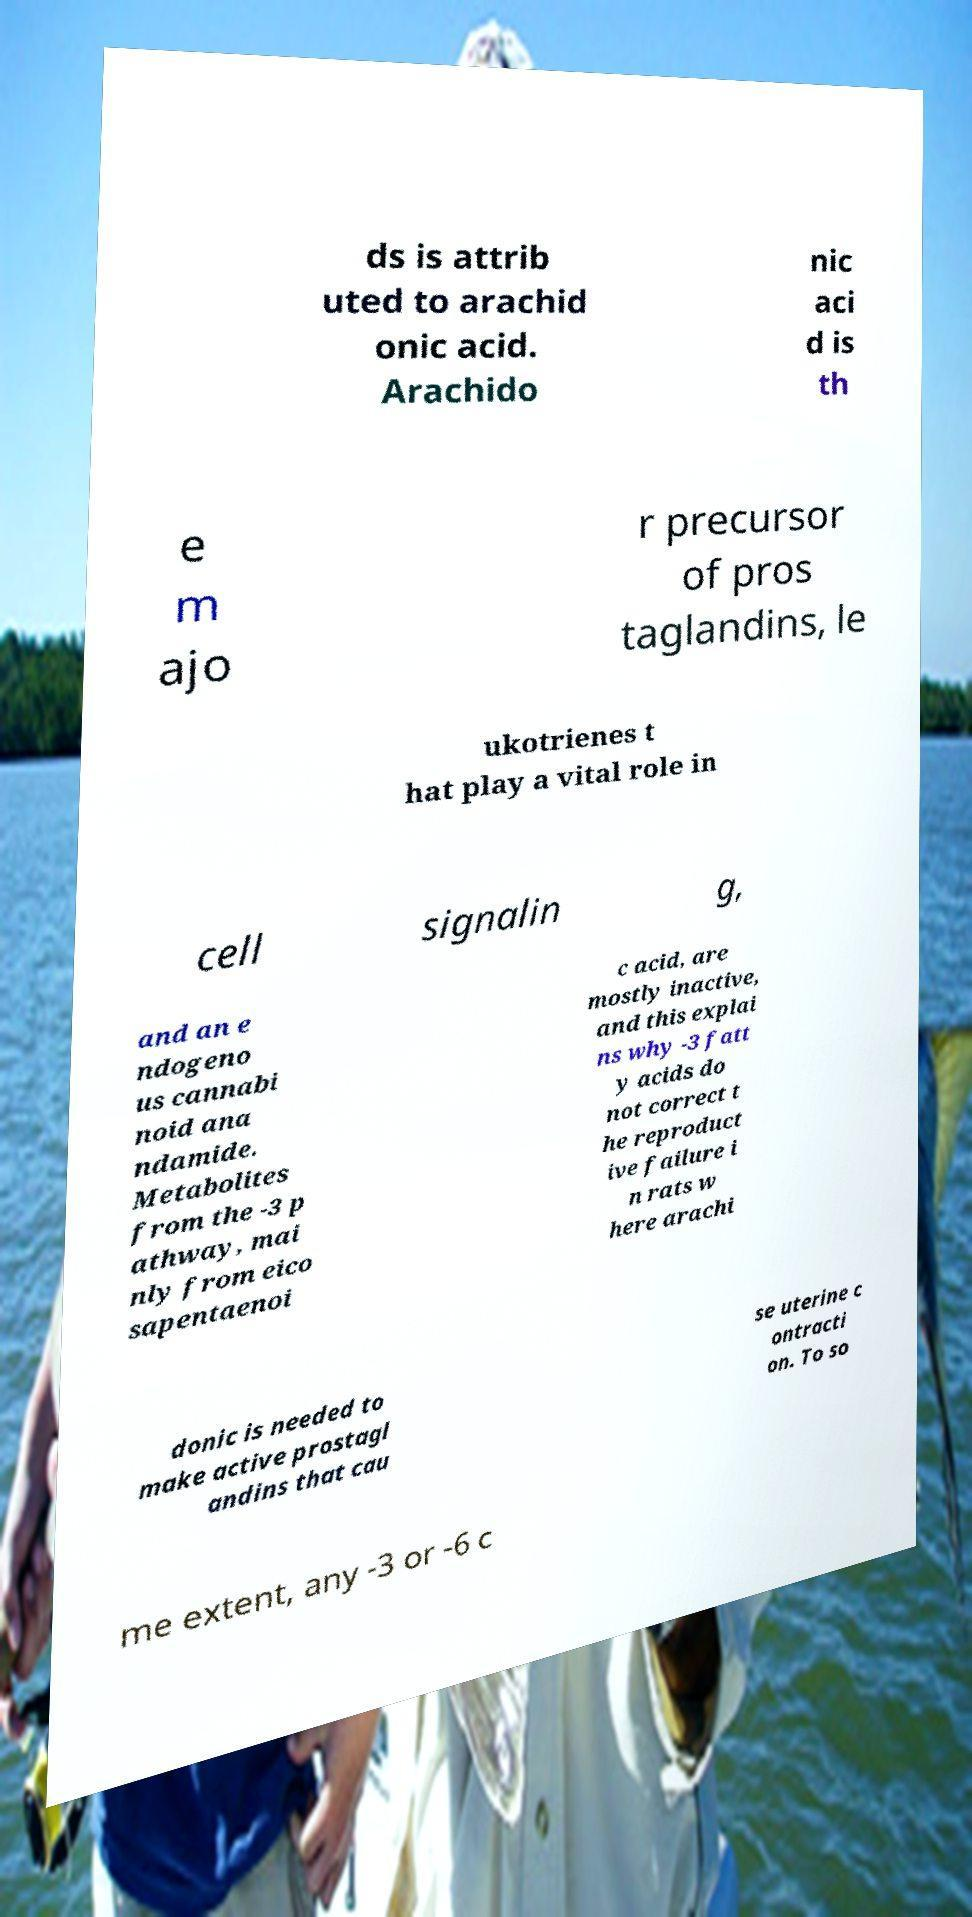Can you accurately transcribe the text from the provided image for me? ds is attrib uted to arachid onic acid. Arachido nic aci d is th e m ajo r precursor of pros taglandins, le ukotrienes t hat play a vital role in cell signalin g, and an e ndogeno us cannabi noid ana ndamide. Metabolites from the -3 p athway, mai nly from eico sapentaenoi c acid, are mostly inactive, and this explai ns why -3 fatt y acids do not correct t he reproduct ive failure i n rats w here arachi donic is needed to make active prostagl andins that cau se uterine c ontracti on. To so me extent, any -3 or -6 c 